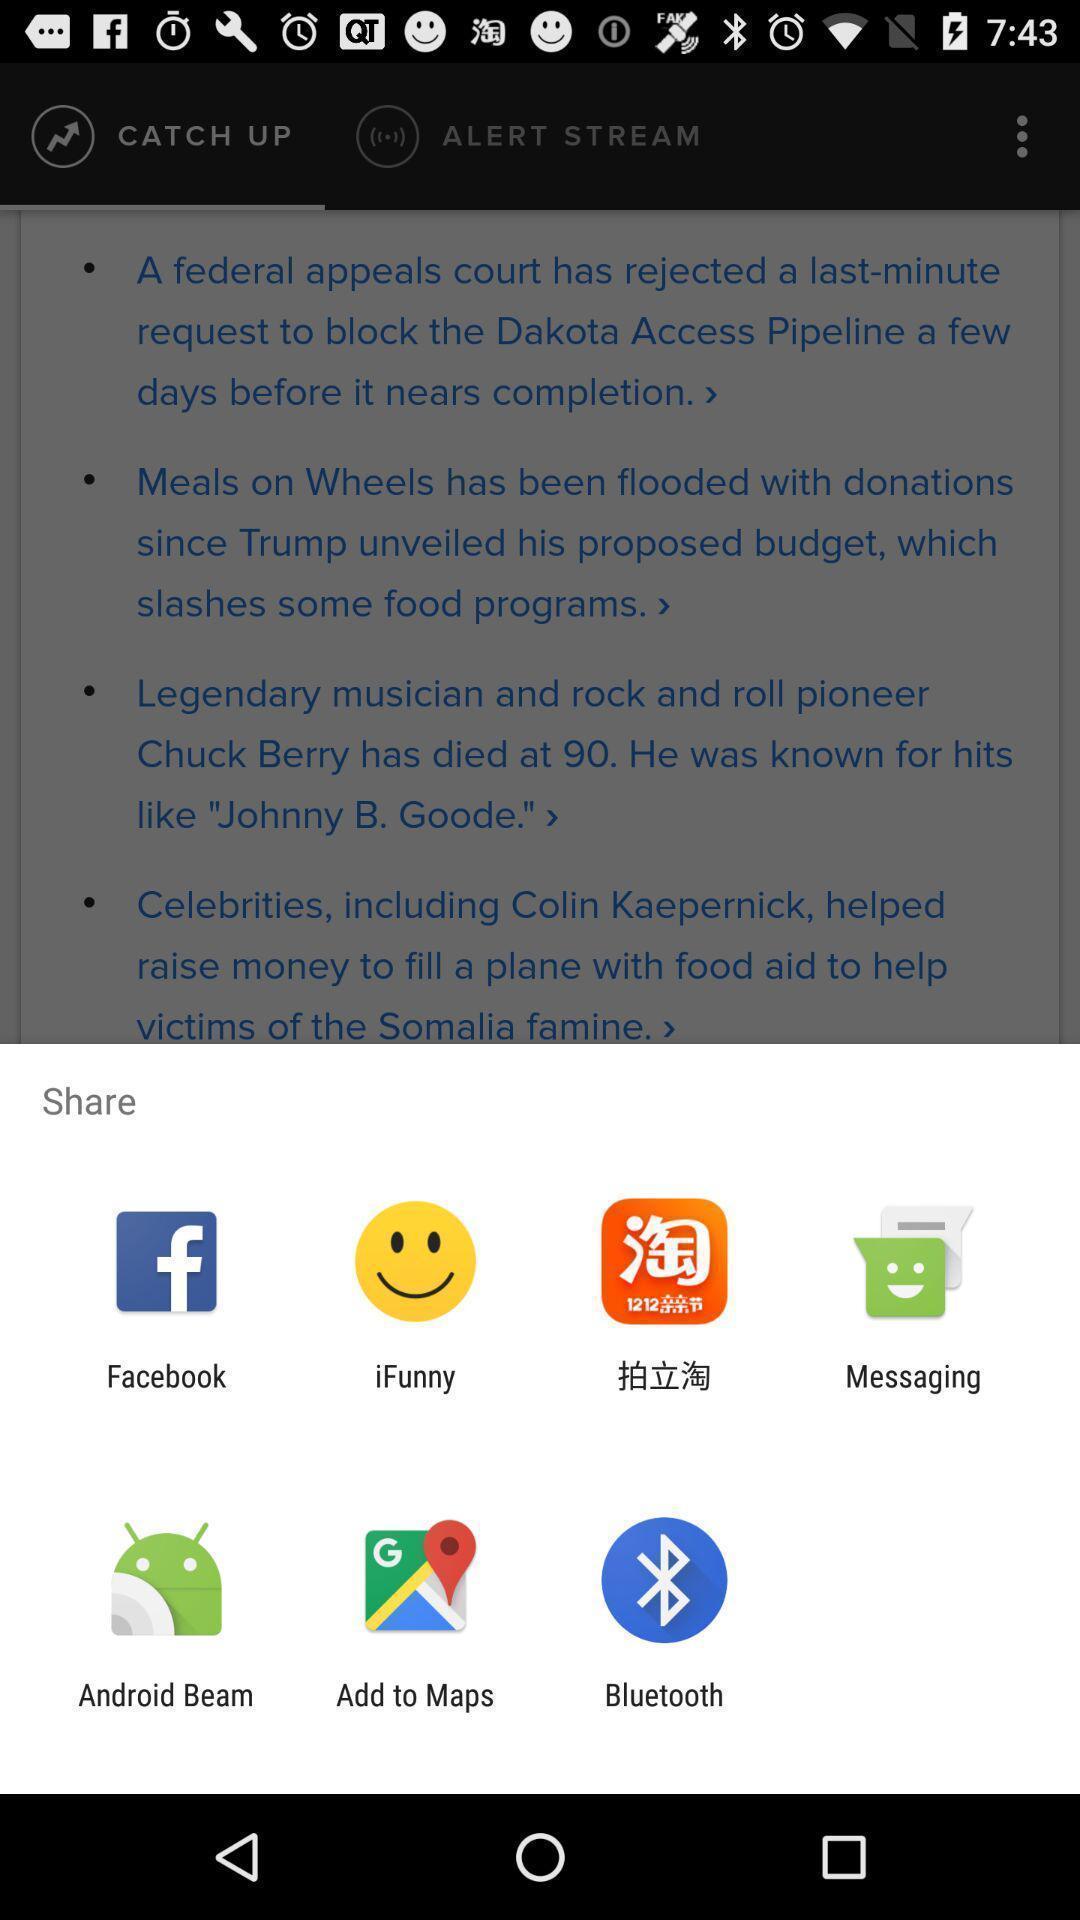What is the overall content of this screenshot? Pop-up showing different applications for sharing information. 